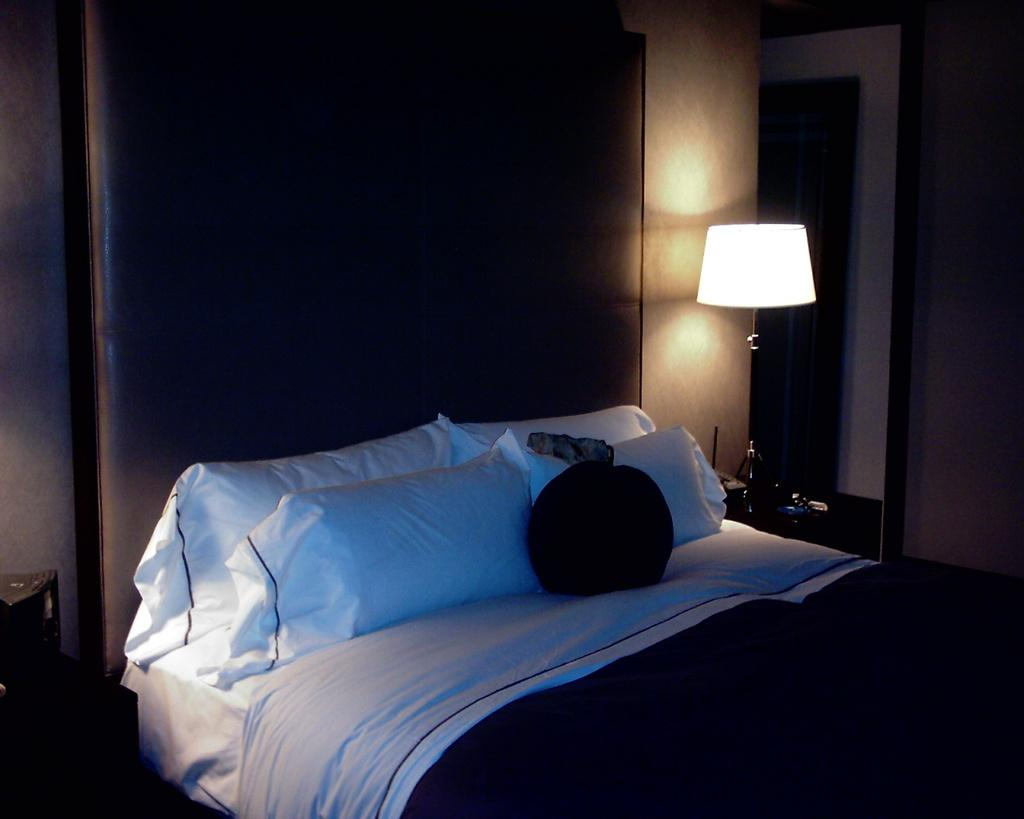What type of room is shown in the image? The image depicts a bedroom. What is the main piece of furniture in the bedroom? There is a bed in the bedroom. What is located beside the bed? There is a lamp and a table with objects on it beside the bed. Can you describe the lighting source in the bedroom? There appears to be a lamp beside the bed. What other item might be used for personal grooming in the bedroom? There appears to be a mirror beside the lamp. What type of animals can be seen at the zoo in the image? There is no zoo present in the image; it depicts a bedroom. What type of fruit is the person holding in the image? There is no fruit visible in the image; it shows a bedroom with a bed, lamp, table, and objects. 